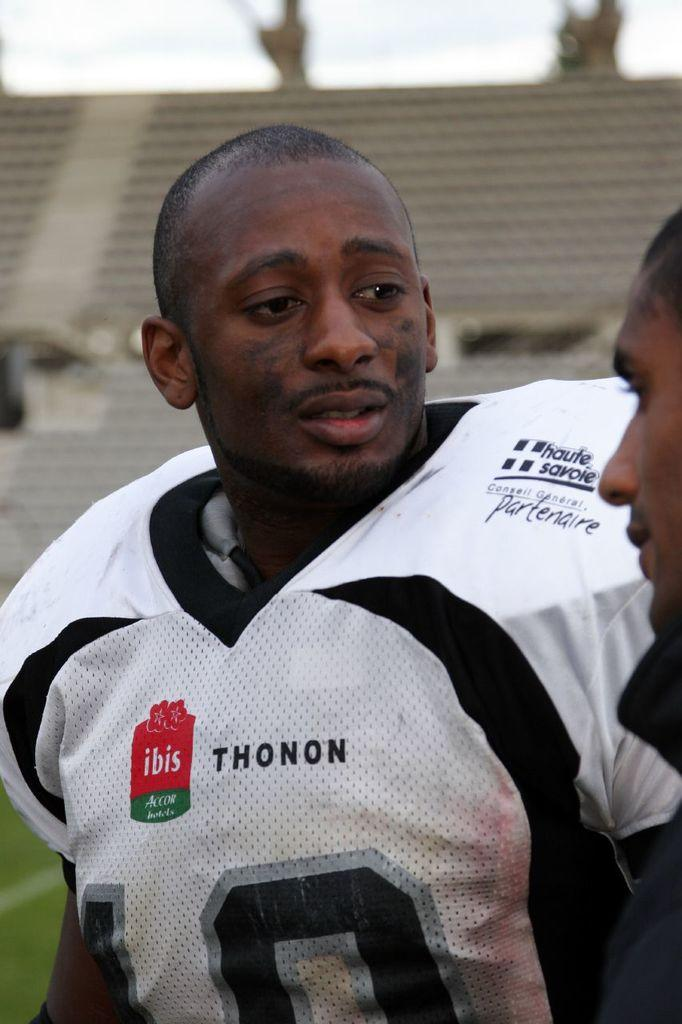<image>
Render a clear and concise summary of the photo. the rugby player who has a white jersey writings as haute savoie  ,sees another person 